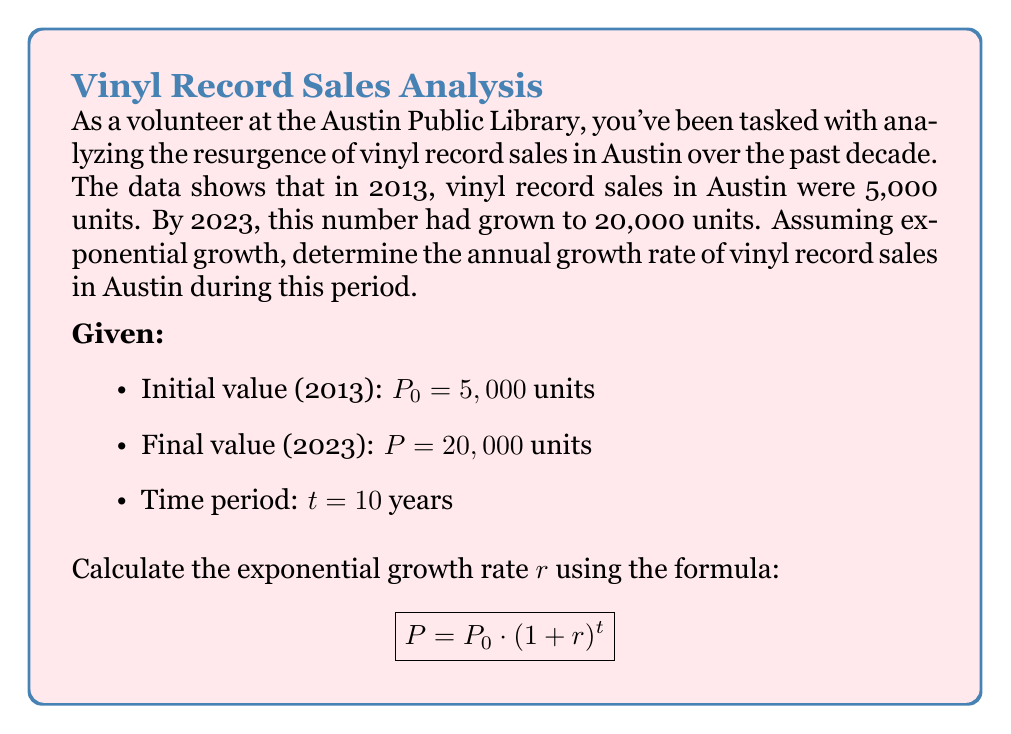Teach me how to tackle this problem. Let's solve this step-by-step:

1) We start with the exponential growth formula:
   $$ P = P_0 \cdot (1 + r)^t $$

2) Substitute the known values:
   $$ 20,000 = 5,000 \cdot (1 + r)^{10} $$

3) Divide both sides by 5,000:
   $$ 4 = (1 + r)^{10} $$

4) Take the 10th root of both sides:
   $$ \sqrt[10]{4} = 1 + r $$

5) Subtract 1 from both sides:
   $$ \sqrt[10]{4} - 1 = r $$

6) Calculate the value:
   $$ r = \sqrt[10]{4} - 1 $$
   $$ r \approx 1.1487 - 1 = 0.1487 $$

7) Convert to a percentage:
   $$ r \approx 0.1487 \times 100\% = 14.87\% $$

Thus, the annual growth rate of vinyl record sales in Austin over the past decade was approximately 14.87%.
Answer: $14.87\%$ 